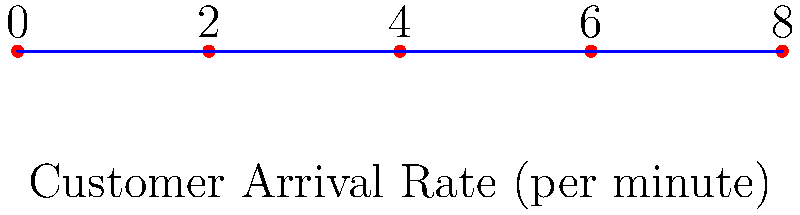As a grocery store owner, you want to determine the minimum number of checkout lanes needed based on customer arrival rates. The graph shows customer arrival rates at different times of the day. If each checkout lane can serve 3 customers per minute, what's the minimum number of lanes needed to avoid long queues? Let's approach this step-by-step:

1. Understand the graph:
   - The x-axis represents different times of the day (0, 2, 4, 6, 8 hours).
   - The y-axis represents the customer arrival rate per minute.

2. Identify the peak arrival rate:
   - The highest point on the graph is at x = 4, which corresponds to 8 customers per minute.

3. Calculate the service capacity needed:
   - Peak arrival rate = 8 customers/minute
   - Each lane can serve 3 customers/minute

4. Determine the number of lanes:
   - Minimum lanes = Peak arrival rate ÷ Service rate per lane
   - Minimum lanes = 8 ÷ 3 ≈ 2.67

5. Round up to the nearest whole number:
   - Since we can't have a fraction of a lane, we round up to 3 lanes.

This ensures that even during peak times, all customers can be served without long queues forming.
Answer: 3 lanes 